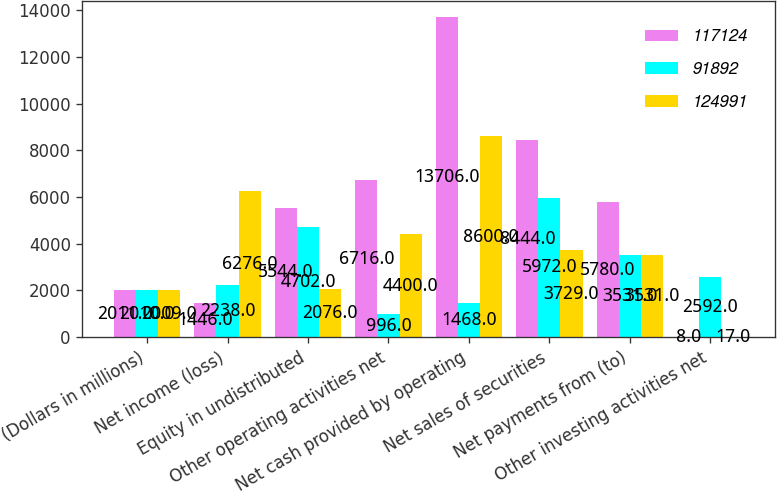<chart> <loc_0><loc_0><loc_500><loc_500><stacked_bar_chart><ecel><fcel>(Dollars in millions)<fcel>Net income (loss)<fcel>Equity in undistributed<fcel>Other operating activities net<fcel>Net cash provided by operating<fcel>Net sales of securities<fcel>Net payments from (to)<fcel>Other investing activities net<nl><fcel>117124<fcel>2011<fcel>1446<fcel>5544<fcel>6716<fcel>13706<fcel>8444<fcel>5780<fcel>8<nl><fcel>91892<fcel>2010<fcel>2238<fcel>4702<fcel>996<fcel>1468<fcel>5972<fcel>3531<fcel>2592<nl><fcel>124991<fcel>2009<fcel>6276<fcel>2076<fcel>4400<fcel>8600<fcel>3729<fcel>3531<fcel>17<nl></chart> 